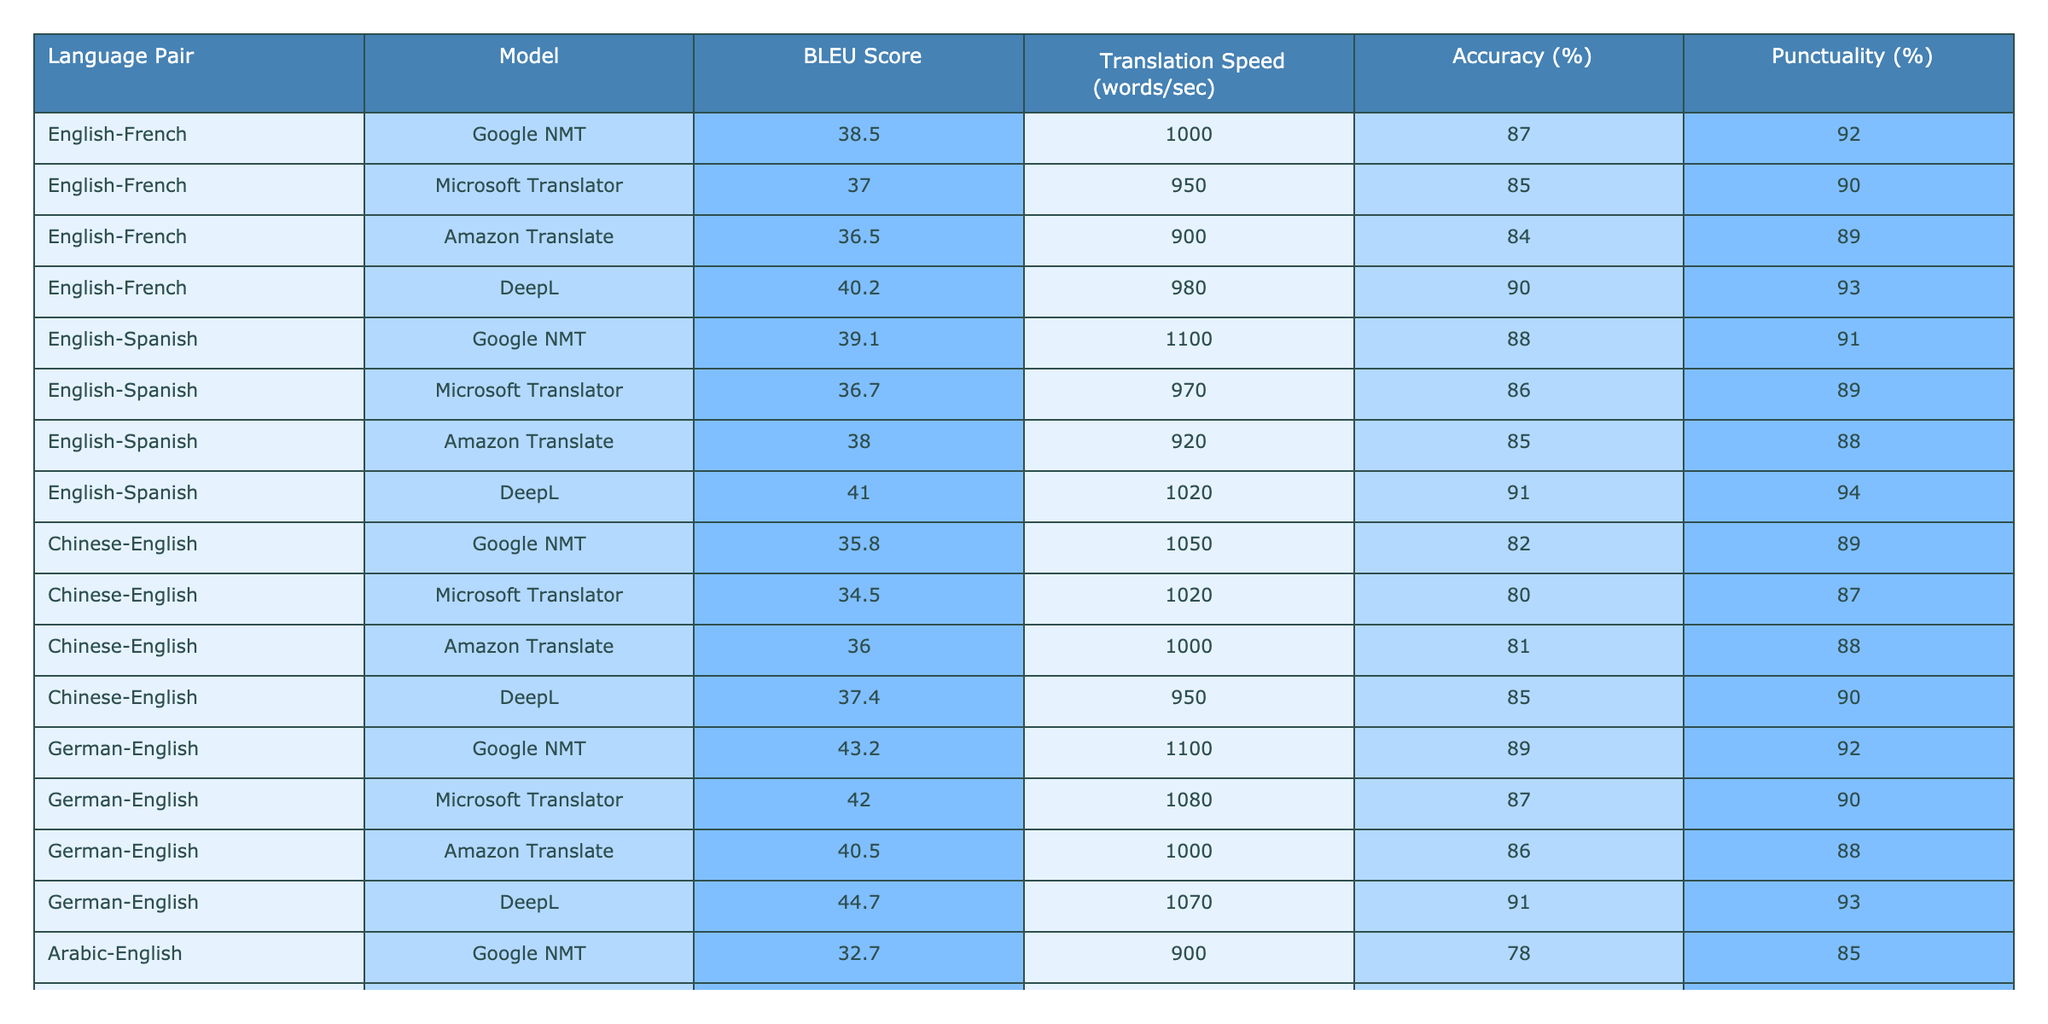What is the BLEU score of the DeepL model for the English-French language pair? The BLEU score for the DeepL model when translating from English to French is clearly listed in the table, which shows it to be 40.2.
Answer: 40.2 Which model has the highest translation speed for the German-English language pair? Looking at the translation speed values from the table for the German-English language pair, the Google NMT model has the highest speed at 1100 words per second.
Answer: Google NMT What is the average accuracy across all models for the English-Spanish language pair? First, we sum the accuracy values for the models translating English to Spanish: (88 + 86 + 85 + 91) = 350. Then, we divide by the number of models (4), yielding an average accuracy of 350/4 = 87.5%.
Answer: 87.5% Is the BLEU score for DeepL higher than that of Microsoft Translator for the Chinese-English language pair? The table shows a BLEU score of 37.4 for DeepL and 34.5 for Microsoft Translator when translating from Chinese to English. Since 37.4 is greater than 34.5, the statement is true.
Answer: Yes Which model has the lowest punctuality percentage for the Arabic-English language pair? Analyzing the punctuality percentages in the table for the Arabic-English translations, the Amazon Translate model has the lowest value of 77%.
Answer: Amazon Translate What is the difference in BLEU scores between the highest and the lowest models for the English-Spanish language pair? For English to Spanish, DeepL has the highest BLEU score at 41.0 and Microsoft Translator has the lowest at 36.7. The difference is 41.0 - 36.7 = 4.3.
Answer: 4.3 For the German-English language pair, which model has the lowest accuracy percentage? The accuracy values for the German-English models are 89%, 87%, 86%, and 91%. The lowest among these is 86%, which is attributed to Amazon Translate.
Answer: Amazon Translate What are the punctuality percentages for all models translating English to French? The punctuality percentages for the English-French translations are: Google NMT 92%, Microsoft Translator 90%, Amazon Translate 89%, and DeepL 93%. Therefore, those values are 92, 90, 89, and 93.
Answer: 92, 90, 89, 93 Compare the translation speeds of the Google NMT model across all language pairs. For the Google NMT model, the translation speeds across the various language pairs are: 1000 (English-French), 1100 (English-Spanish), 1050 (Chinese-English), and 1100 (German-English). The average speed is (1000 + 1100 + 1050 + 1100) / 4 = 1037.5.
Answer: 1037.5 Which language pair shows the best overall performance based on BLEU scores? Analyzing the BLEU scores in the table, the German-English language pair shows the highest score at 44.7 for DeepL, which is greater than all other pairs.
Answer: German-English 